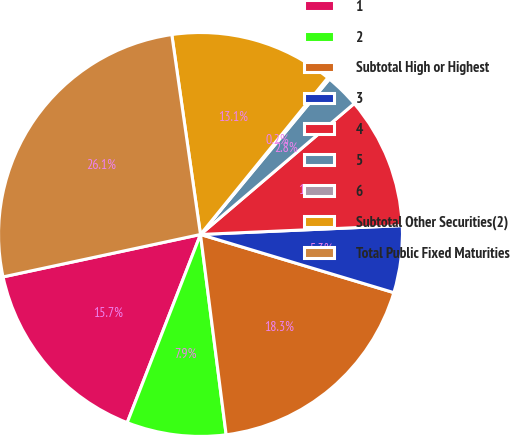Convert chart to OTSL. <chart><loc_0><loc_0><loc_500><loc_500><pie_chart><fcel>1<fcel>2<fcel>Subtotal High or Highest<fcel>3<fcel>4<fcel>5<fcel>6<fcel>Subtotal Other Securities(2)<fcel>Total Public Fixed Maturities<nl><fcel>15.72%<fcel>7.94%<fcel>18.32%<fcel>5.35%<fcel>10.53%<fcel>2.75%<fcel>0.16%<fcel>13.13%<fcel>26.1%<nl></chart> 